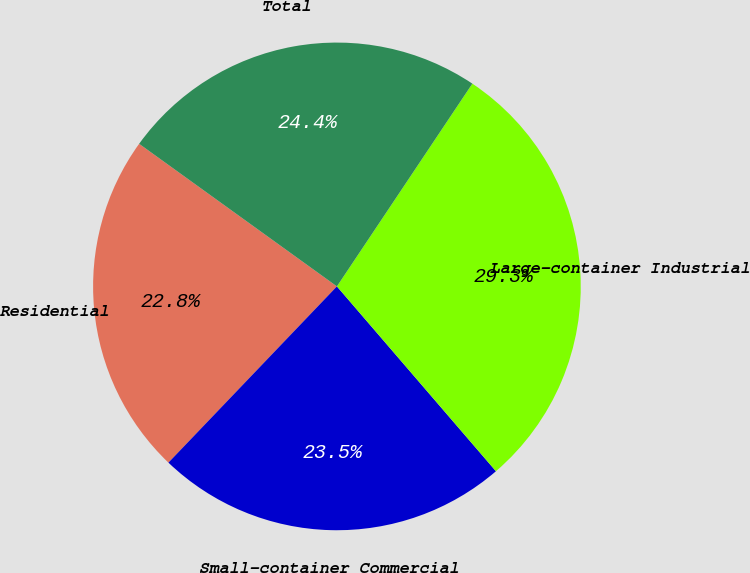<chart> <loc_0><loc_0><loc_500><loc_500><pie_chart><fcel>Residential<fcel>Small-container Commercial<fcel>Large-container Industrial<fcel>Total<nl><fcel>22.8%<fcel>23.45%<fcel>29.32%<fcel>24.43%<nl></chart> 